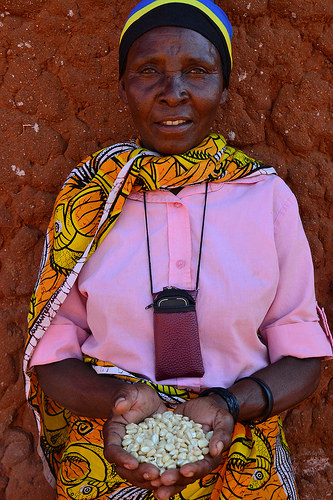<image>
Is there a beans on the woman? Yes. Looking at the image, I can see the beans is positioned on top of the woman, with the woman providing support. 